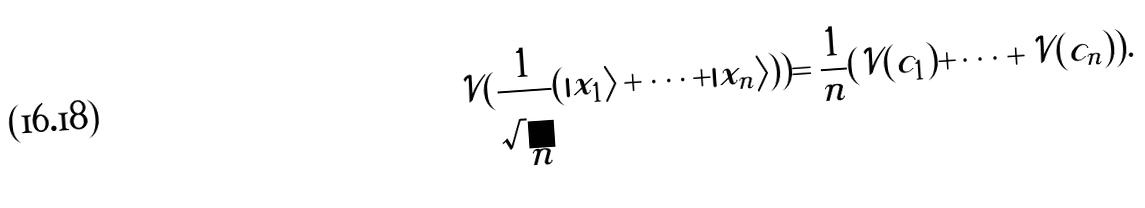Convert formula to latex. <formula><loc_0><loc_0><loc_500><loc_500>\mathcal { V } ( \frac { 1 } { \sqrt { n } } ( | x _ { 1 } \rangle + \dots + | x _ { n } \rangle ) ) = \frac { 1 } { n } ( \mathcal { V } ( c _ { 1 } ) + \dots + \mathcal { V } ( c _ { n } ) ) .</formula> 